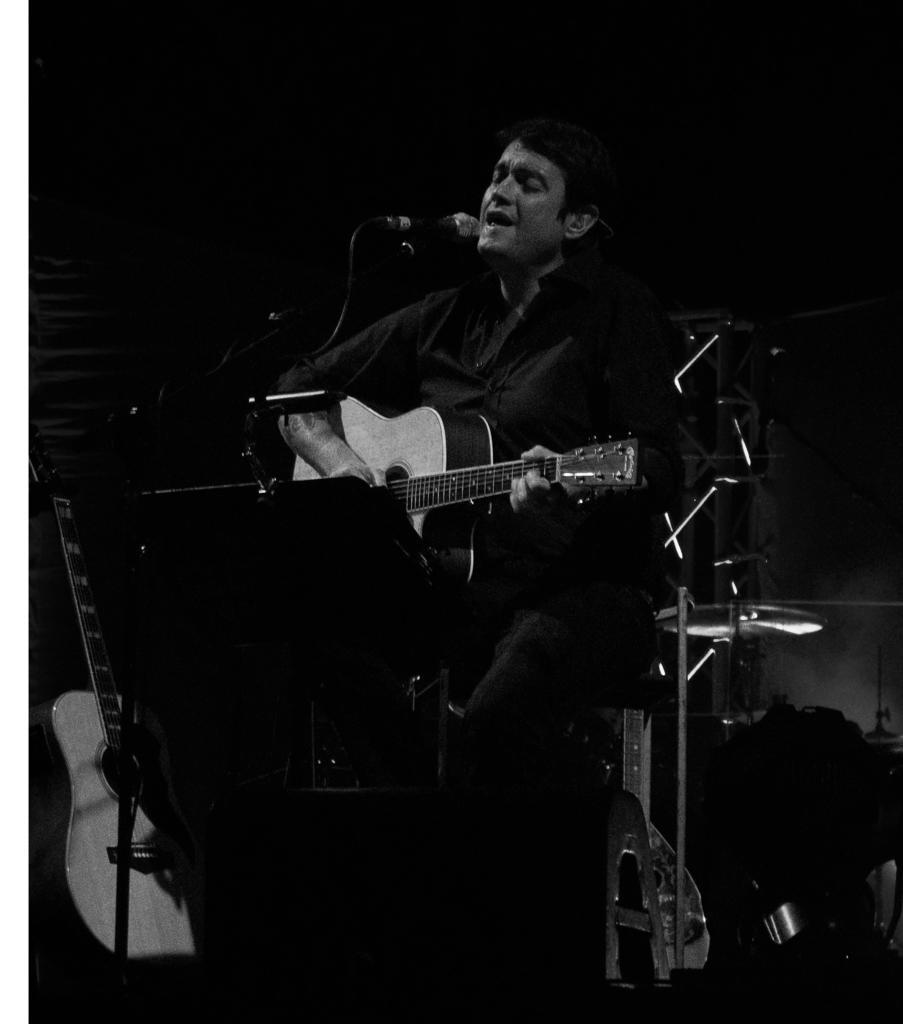Can you describe this image briefly? In this image I can see a man is standing and holding a guitar. In front of him I can see a mic and a stand. I can also see another guitar over here. 